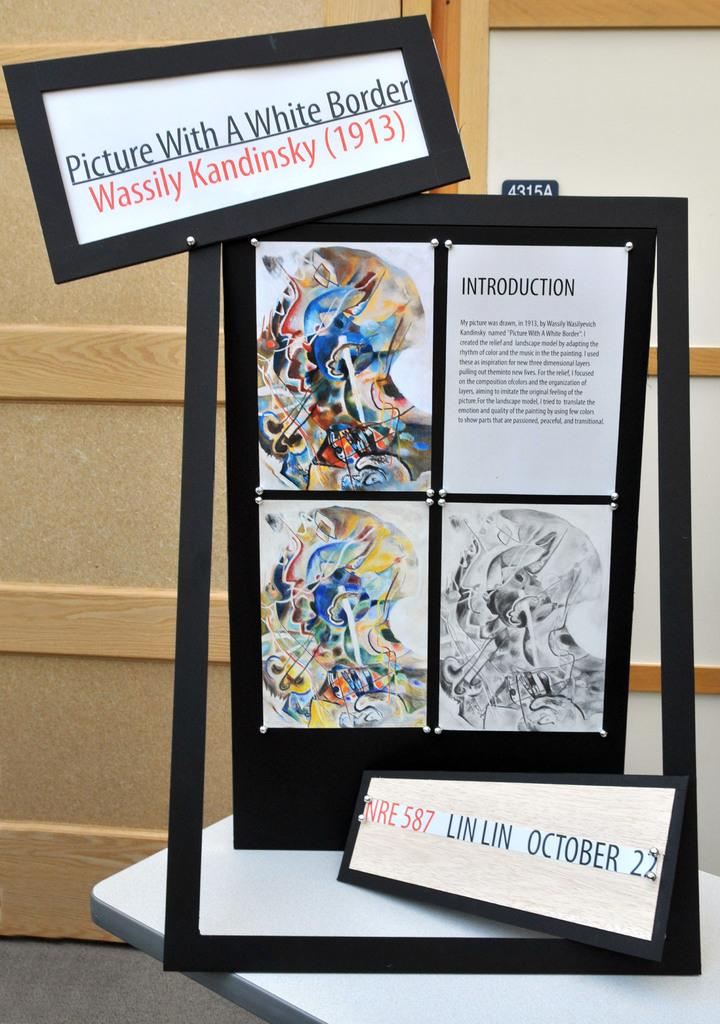<image>
Create a compact narrative representing the image presented. In 1913, an artist by the name of Wassily Kandinsky created a piece of art titled Picture With A White Border. 